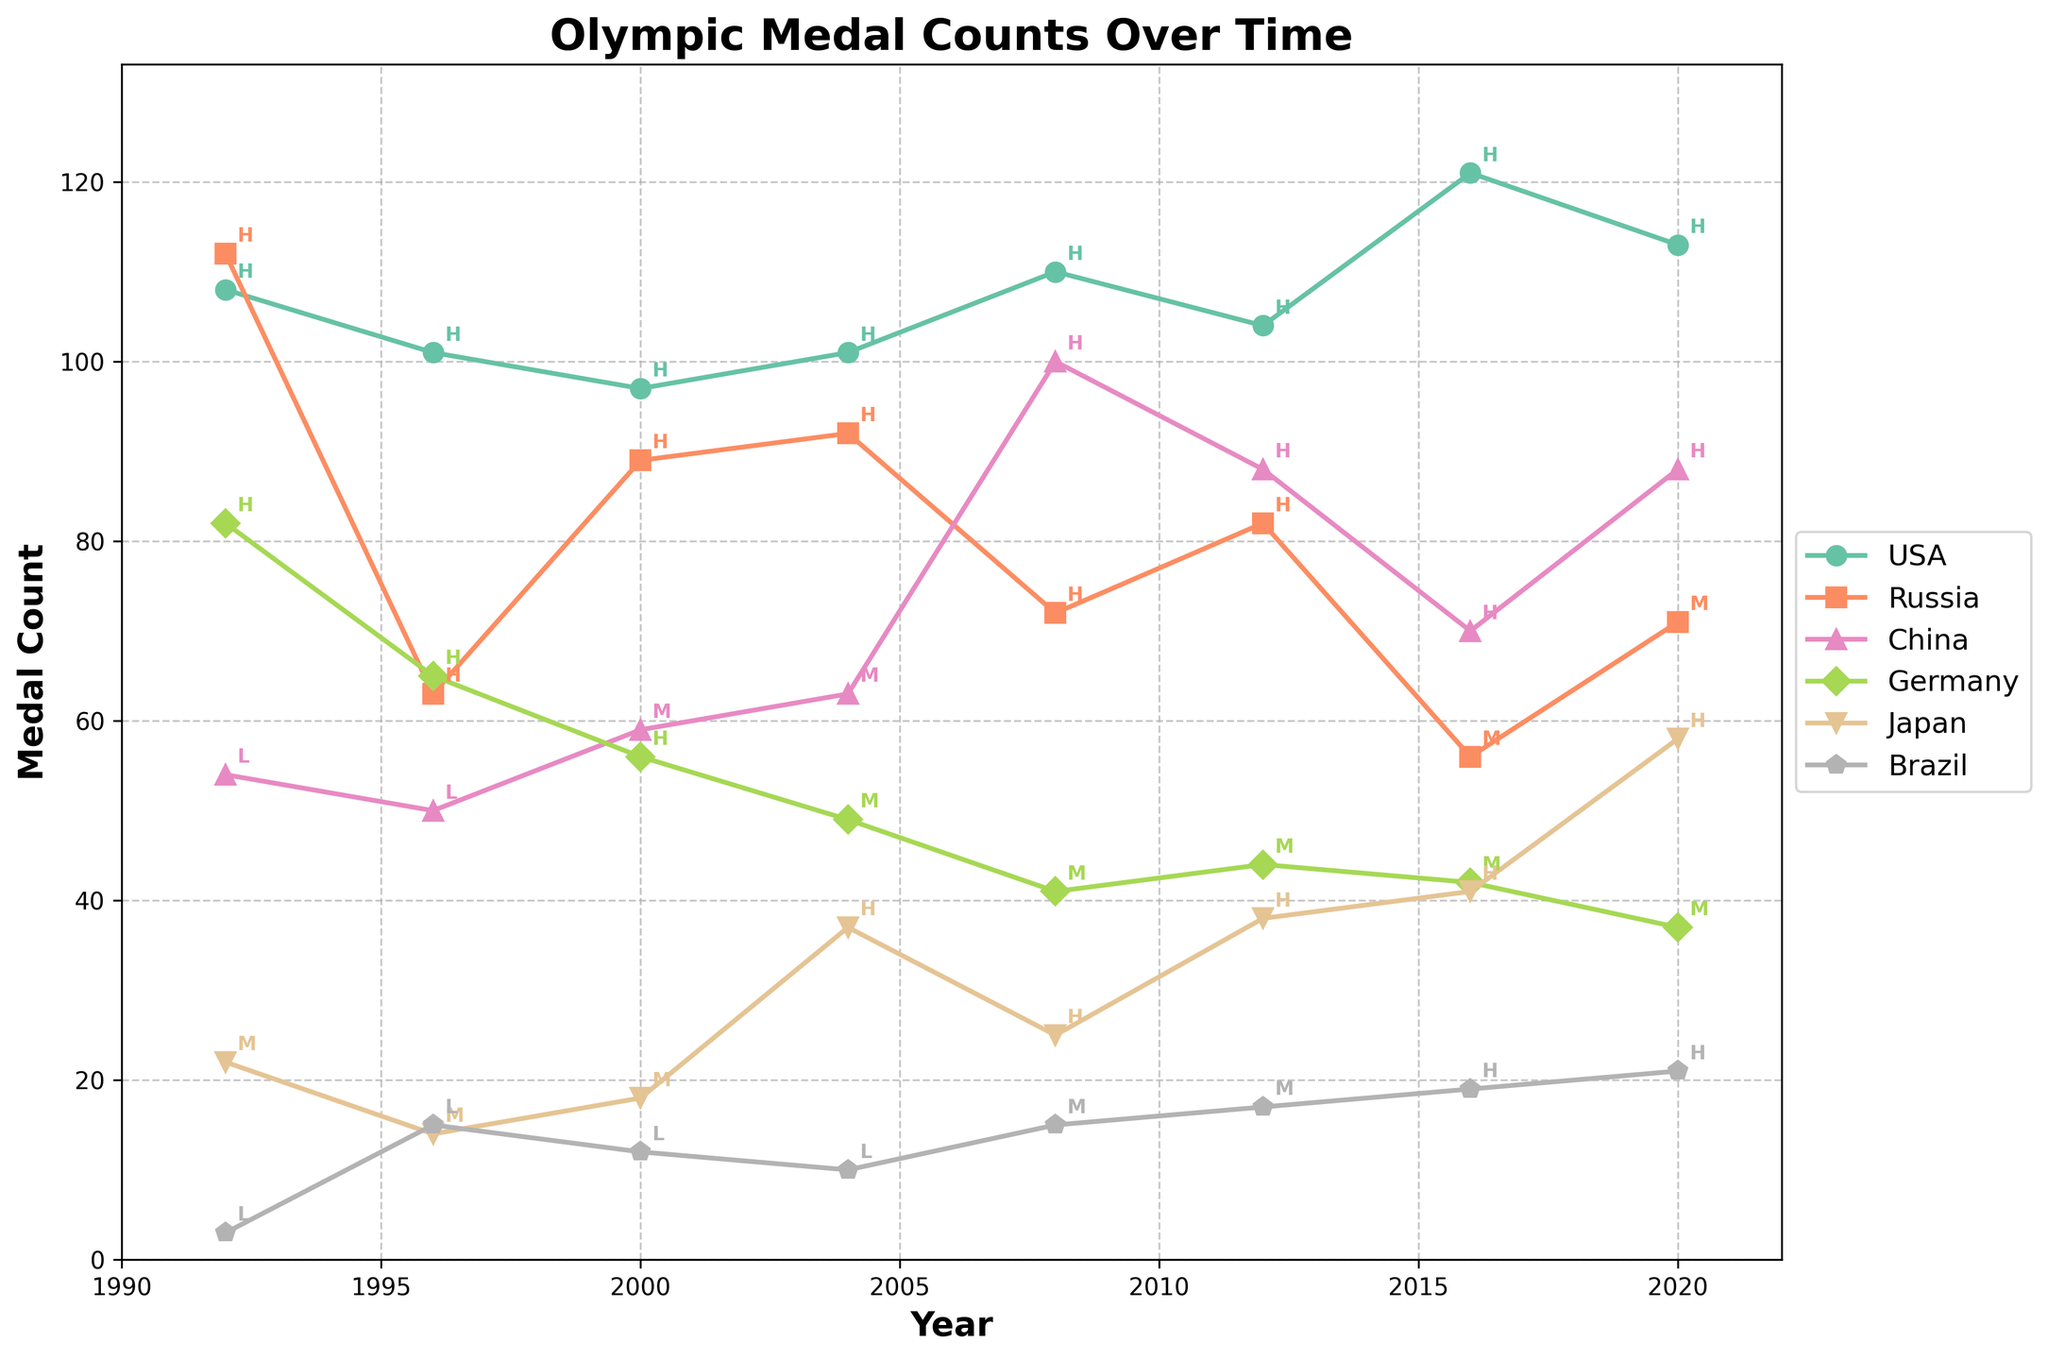Which country had the highest medal count in 2016? The highest point on the plot for the year 2016 shows the USA with 121 medals.
Answer: USA Between 2012 and 2016, did Russia's medal count increase or decrease? From 2012 to 2016, Russia's medal count went from 82 to 56, which is a decrease.
Answer: Decrease Comparing the medal counts in 2008, which country had the second-highest number of medals? The plot shows that the country with the highest medal count in 2008 was the USA with 110 medals, followed by China with 100 medals.
Answer: China What was the trend in Germany’s medal count from 1996 to 2004? Germany's medal count decreased from 65 in 1996 to 56 in 2000 and then further down to 49 in 2004.
Answer: Decreasing Which country showed the most significant increase in medal count from 2004 to 2008? The medal count for China increased the most from 63 in 2004 to 100 in 2008.
Answer: China Which countries had a high PE Program Strength in 2020 and what were their medal counts? In 2020, the USA had 113 medals, China had 88 medals, and Japan had 58 medals, all with a high PE Program Strength.
Answer: USA, China, Japan How did Japan’s medal count change between 1992 and 2020? Japan's medal count increased from 22 in 1992 to 58 in 2020, showing an overall positive trend.
Answer: Increase What were the PE Program Strengths annotated in the 1996 medal counts for USA and Russia? The annotations indicate that both USA and Russia had a high PE Program Strength in 1996.
Answer: High Compare the medal counts for Brazil in 1996 and 2020. By how many medals did the count change? Brazil's medal count increased from 15 in 1996 to 21 in 2020, resulting in an increase of 6 medals.
Answer: Increased by 6 What is the trend of China's medal counts from 1992 to 2020 in terms of PE Program Strength? China's PE Program Strength started as low in 1992 and 1996, moved to medium by 2000 and 2004, and then to high from 2008 onwards. Their medal count generally increased with this transition in PE Program Strength.
Answer: Increasing with stronger PE programs 